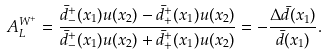Convert formula to latex. <formula><loc_0><loc_0><loc_500><loc_500>A _ { L } ^ { W ^ { + } } = \frac { { \bar { d } } ^ { + } _ { - } ( x _ { 1 } ) u ( x _ { 2 } ) - { \bar { d } } ^ { + } _ { + } ( x _ { 1 } ) u ( x _ { 2 } ) } { { \bar { d } } ^ { + } _ { - } ( x _ { 1 } ) u ( x _ { 2 } ) + { \bar { d } } ^ { + } _ { + } ( x _ { 1 } ) u ( x _ { 2 } ) } = - \frac { \Delta \bar { d } ( x _ { 1 } ) } { \bar { d } ( x _ { 1 } ) } .</formula> 